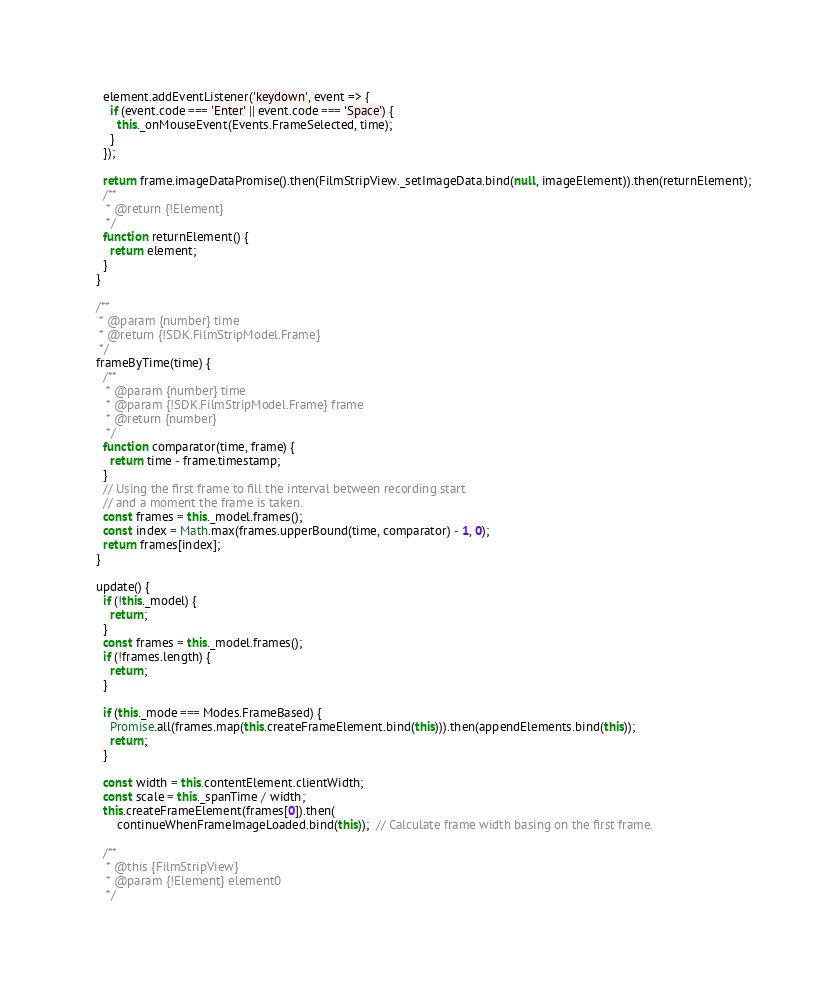Convert code to text. <code><loc_0><loc_0><loc_500><loc_500><_JavaScript_>    element.addEventListener('keydown', event => {
      if (event.code === 'Enter' || event.code === 'Space') {
        this._onMouseEvent(Events.FrameSelected, time);
      }
    });

    return frame.imageDataPromise().then(FilmStripView._setImageData.bind(null, imageElement)).then(returnElement);
    /**
     * @return {!Element}
     */
    function returnElement() {
      return element;
    }
  }

  /**
   * @param {number} time
   * @return {!SDK.FilmStripModel.Frame}
   */
  frameByTime(time) {
    /**
     * @param {number} time
     * @param {!SDK.FilmStripModel.Frame} frame
     * @return {number}
     */
    function comparator(time, frame) {
      return time - frame.timestamp;
    }
    // Using the first frame to fill the interval between recording start
    // and a moment the frame is taken.
    const frames = this._model.frames();
    const index = Math.max(frames.upperBound(time, comparator) - 1, 0);
    return frames[index];
  }

  update() {
    if (!this._model) {
      return;
    }
    const frames = this._model.frames();
    if (!frames.length) {
      return;
    }

    if (this._mode === Modes.FrameBased) {
      Promise.all(frames.map(this.createFrameElement.bind(this))).then(appendElements.bind(this));
      return;
    }

    const width = this.contentElement.clientWidth;
    const scale = this._spanTime / width;
    this.createFrameElement(frames[0]).then(
        continueWhenFrameImageLoaded.bind(this));  // Calculate frame width basing on the first frame.

    /**
     * @this {FilmStripView}
     * @param {!Element} element0
     */</code> 